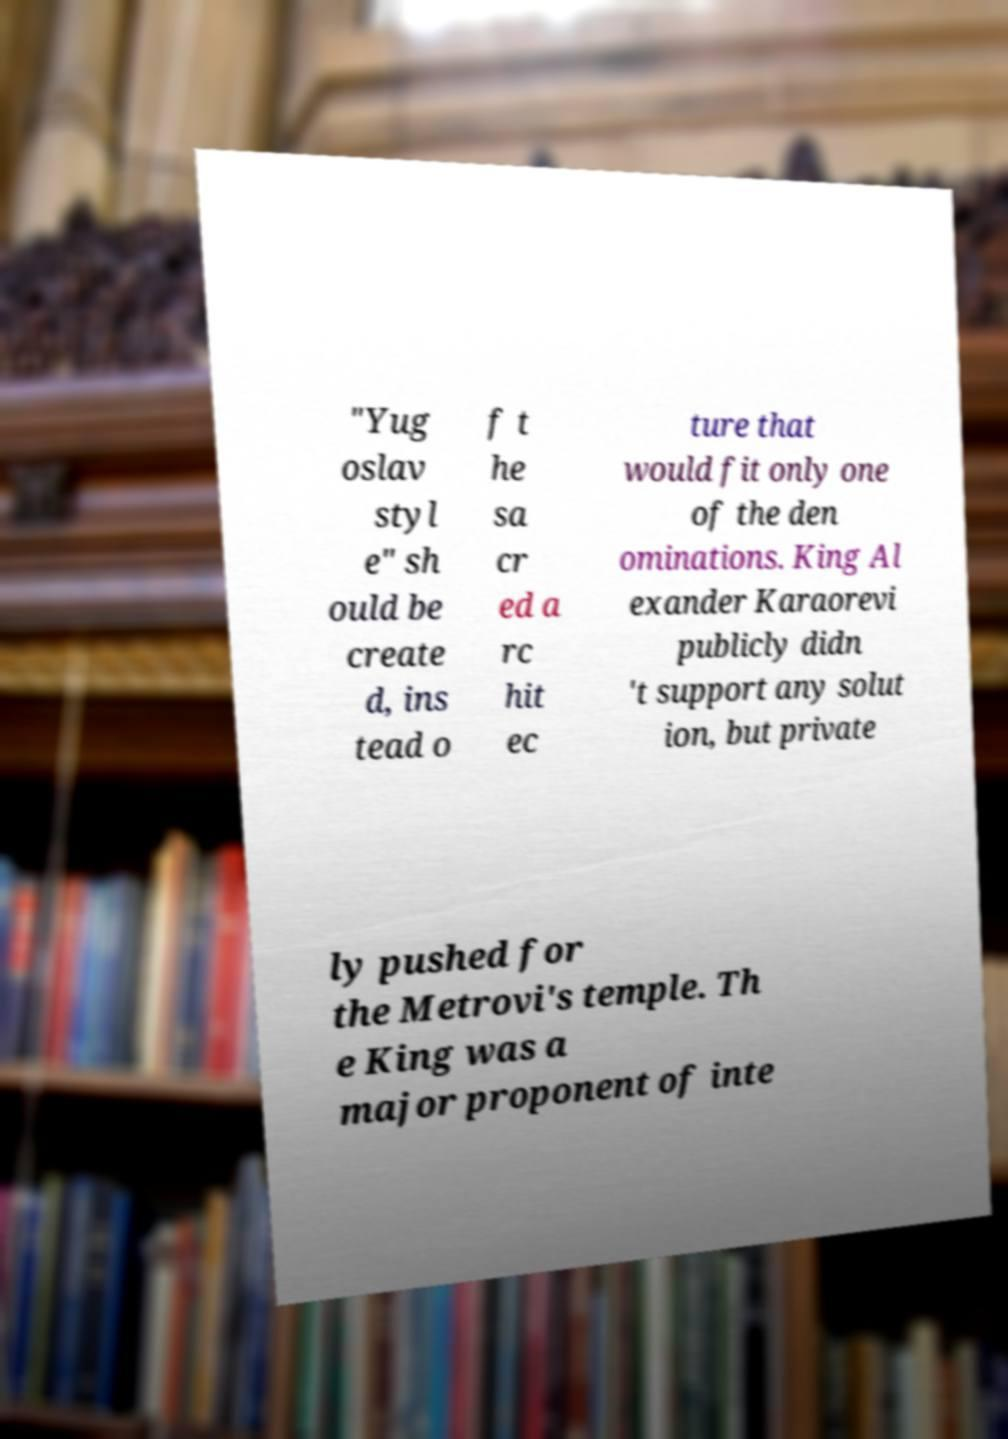Please identify and transcribe the text found in this image. "Yug oslav styl e" sh ould be create d, ins tead o f t he sa cr ed a rc hit ec ture that would fit only one of the den ominations. King Al exander Karaorevi publicly didn 't support any solut ion, but private ly pushed for the Metrovi's temple. Th e King was a major proponent of inte 